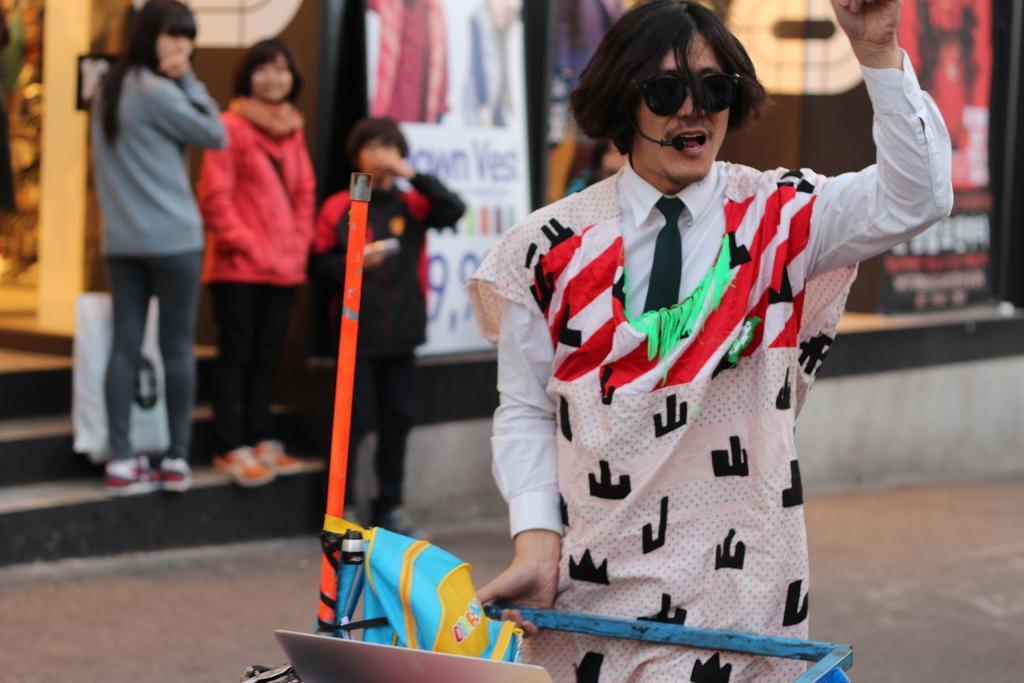Could you give a brief overview of what you see in this image? In this image we can see a person wearing goggles and mic. And the person is holding something. Also there is a bag. In the background there are few people. Also there are steps. And we can see a banner and a glass wall. 